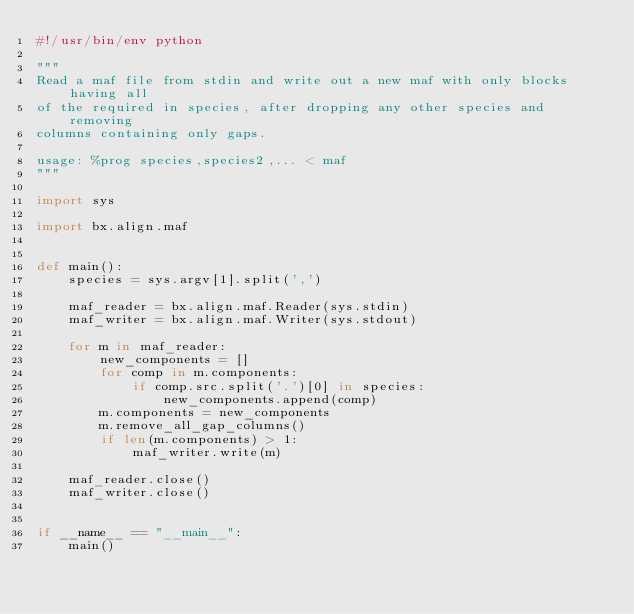Convert code to text. <code><loc_0><loc_0><loc_500><loc_500><_Python_>#!/usr/bin/env python

"""
Read a maf file from stdin and write out a new maf with only blocks having all
of the required in species, after dropping any other species and removing
columns containing only gaps.

usage: %prog species,species2,... < maf
"""

import sys

import bx.align.maf


def main():
    species = sys.argv[1].split(',')

    maf_reader = bx.align.maf.Reader(sys.stdin)
    maf_writer = bx.align.maf.Writer(sys.stdout)

    for m in maf_reader:
        new_components = []
        for comp in m.components:
            if comp.src.split('.')[0] in species:
                new_components.append(comp)
        m.components = new_components
        m.remove_all_gap_columns()
        if len(m.components) > 1:
            maf_writer.write(m)

    maf_reader.close()
    maf_writer.close()


if __name__ == "__main__":
    main()
</code> 